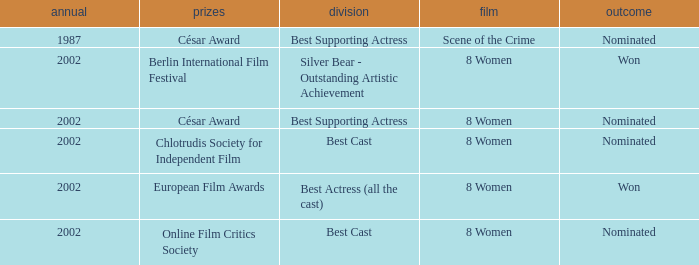In what year was the movie 8 women up for a César Award? 2002.0. 